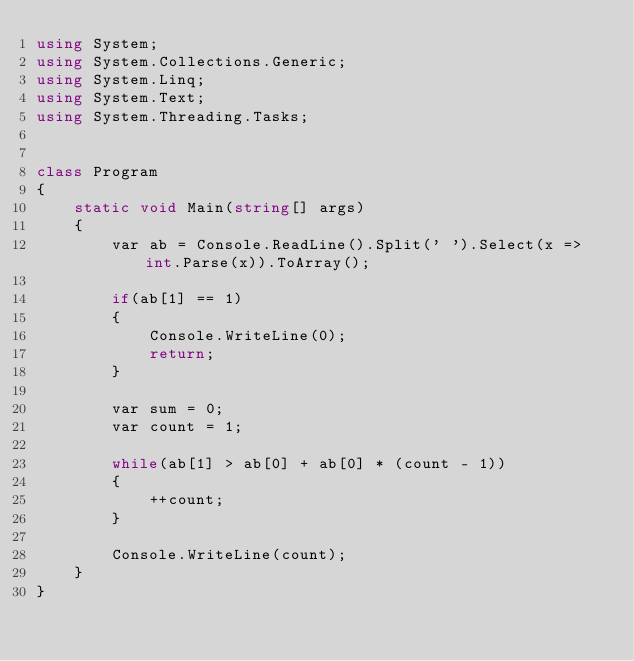Convert code to text. <code><loc_0><loc_0><loc_500><loc_500><_C#_>using System;
using System.Collections.Generic;
using System.Linq;
using System.Text;
using System.Threading.Tasks;


class Program
{
    static void Main(string[] args)
    {
        var ab = Console.ReadLine().Split(' ').Select(x => int.Parse(x)).ToArray();

        if(ab[1] == 1)
        {
            Console.WriteLine(0);
            return;
        }

        var sum = 0;
        var count = 1;

        while(ab[1] > ab[0] + ab[0] * (count - 1))
        {
            ++count;
        }

        Console.WriteLine(count);
    }
}</code> 